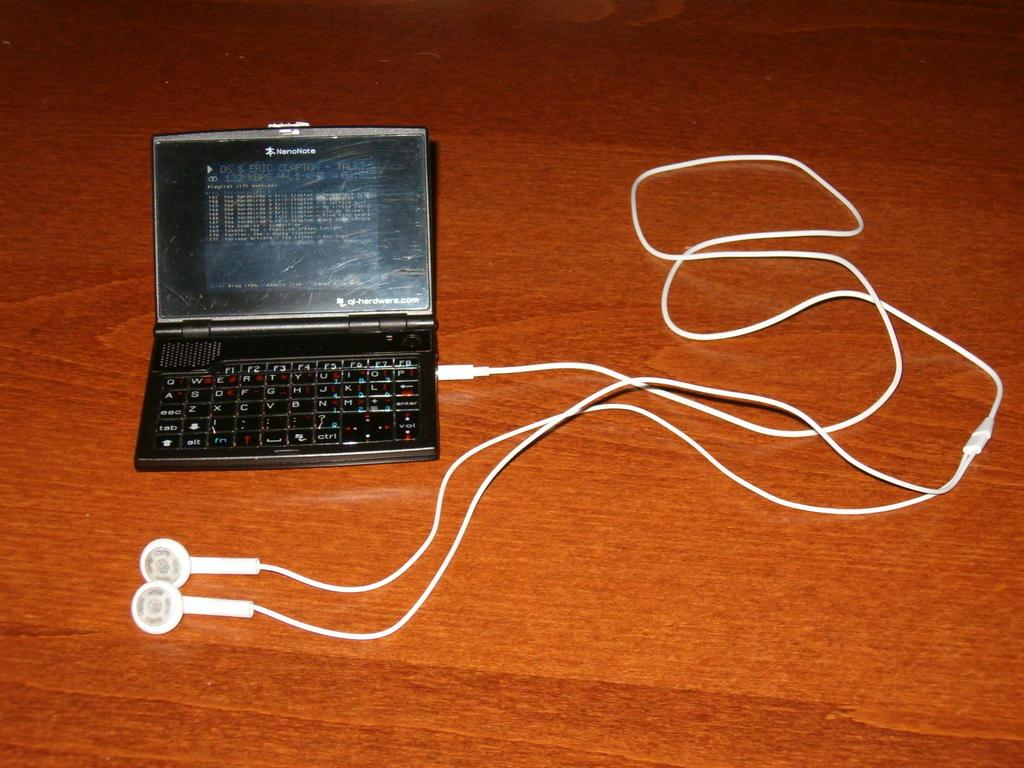<image>
Render a clear and concise summary of the photo. A NanoNote phone with a white cord coming out of it 